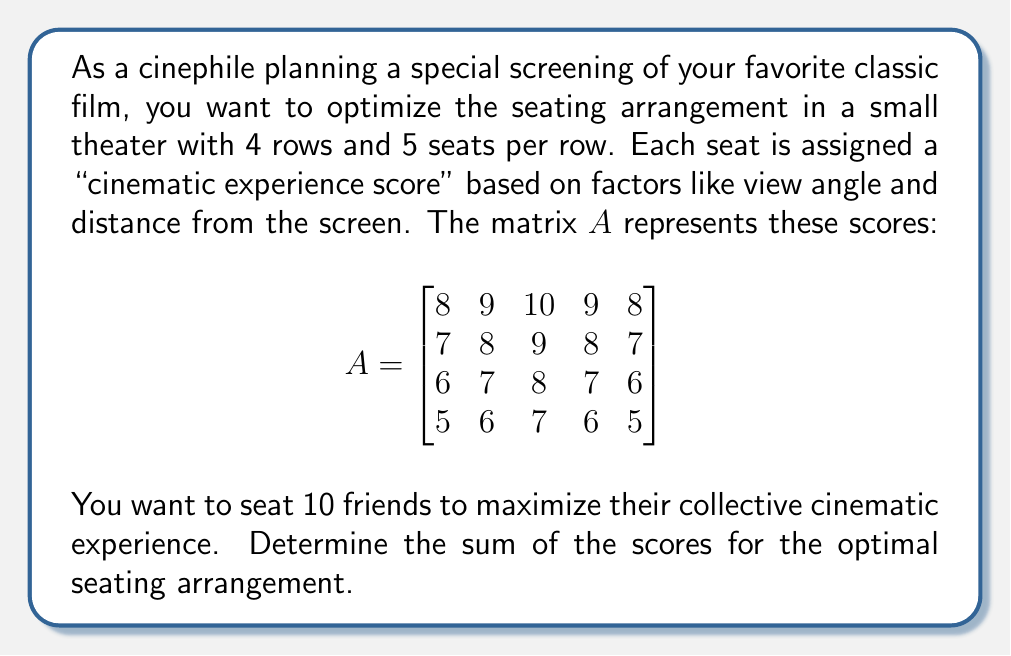Teach me how to tackle this problem. To solve this problem, we'll follow these steps:

1) First, we need to understand that we're looking for the 10 highest values in the matrix $A$. These will represent the best seats for the optimal cinematic experience.

2) Let's order all the elements of $A$ from highest to lowest:
   10, 9, 9, 9, 8, 8, 8, 8, 7, 7, 7, 7, 7, 6, 6, 6, 6, 5, 5, 5

3) The 10 highest values are:
   10, 9, 9, 9, 8, 8, 8, 8, 7, 7

4) Now, we need to sum these 10 values:
   $10 + 9 + 9 + 9 + 8 + 8 + 8 + 8 + 7 + 7 = 83$

5) We can verify this result by looking at the matrix. The optimal seating arrangement would be:

$$\begin{bmatrix}
\textbf{8} & \textbf{9} & \textbf{10} & \textbf{9} & \textbf{8} \\
\textbf{7} & \textbf{8} & \textbf{9} & \textbf{8} & \textbf{7} \\
6 & 7 & 8 & 7 & 6 \\
5 & 6 & 7 & 6 & 5
\end{bmatrix}$$

   Where the bold numbers represent the selected seats.

6) The sum of these bold numbers is indeed 83, confirming our calculation.

Therefore, the sum of the scores for the optimal seating arrangement is 83.
Answer: 83 